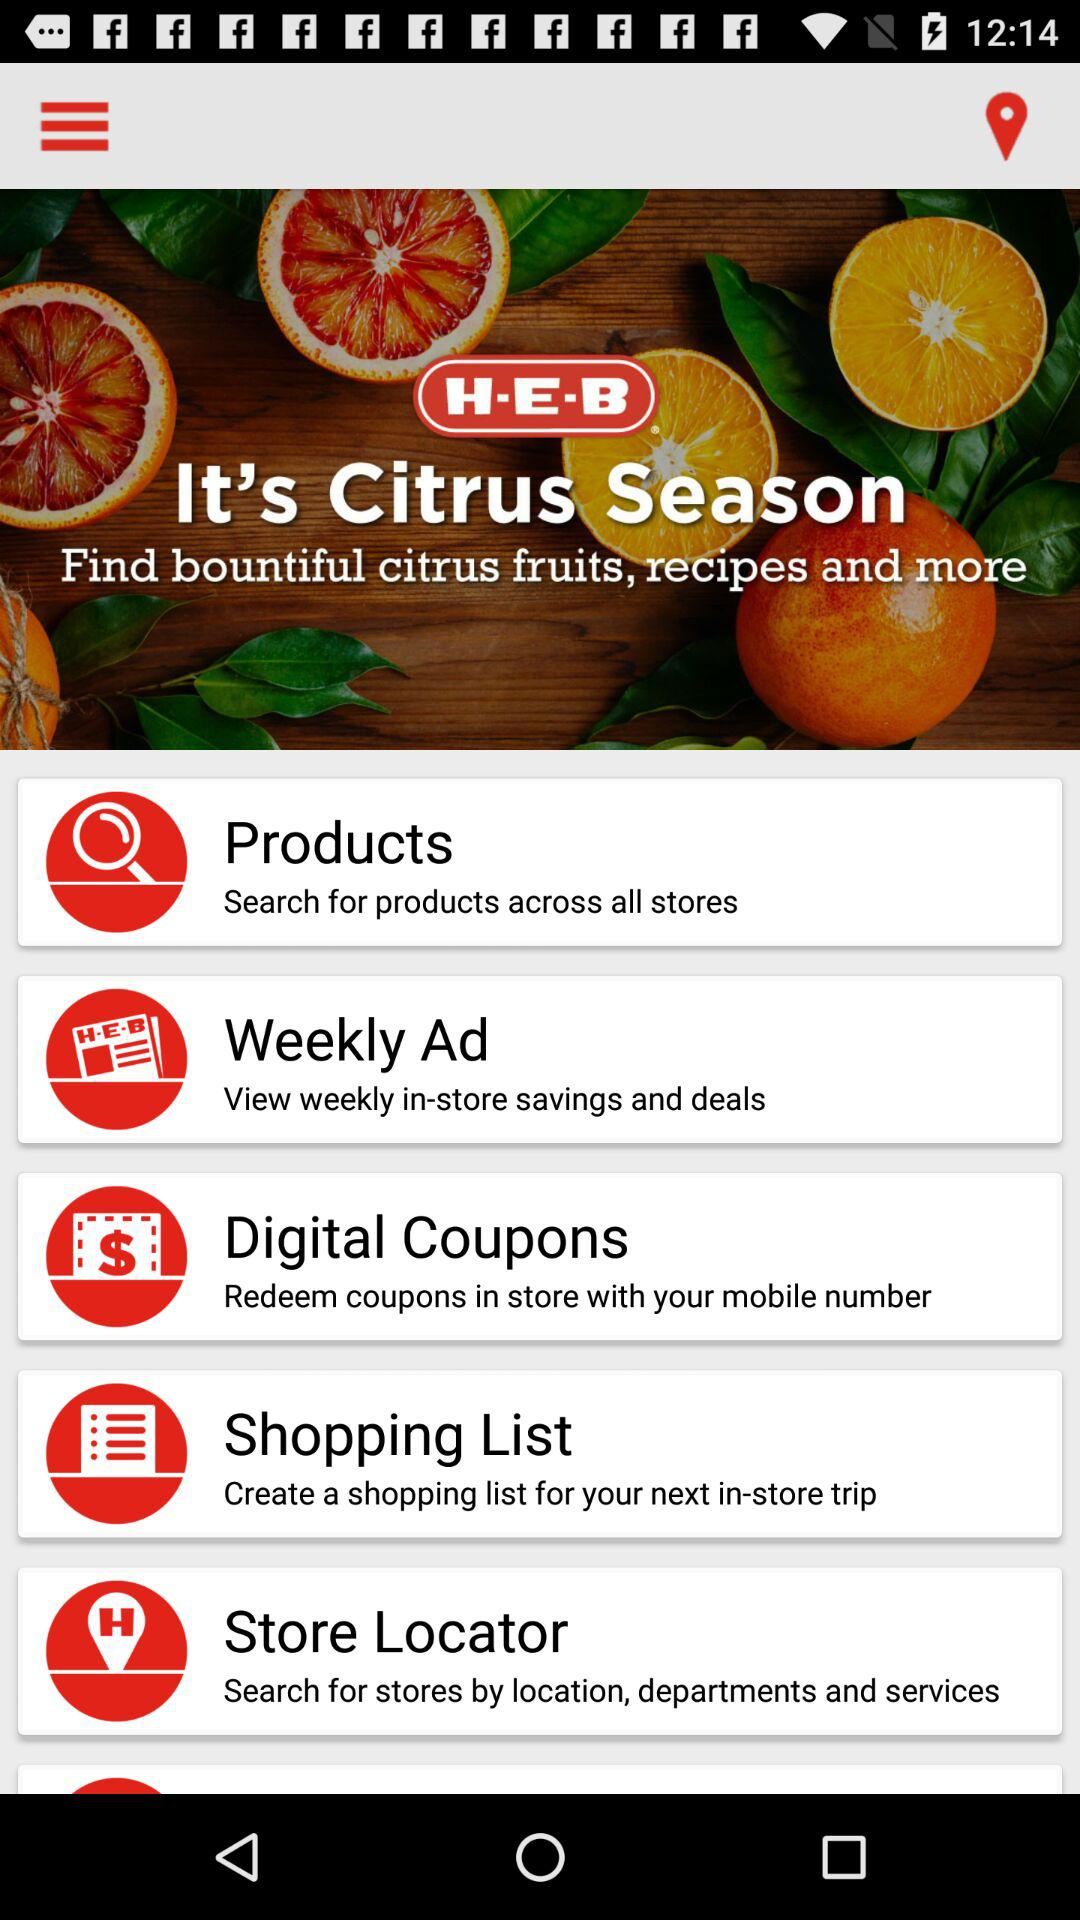What is the name of the application? The name of the application is "H-E-B". 